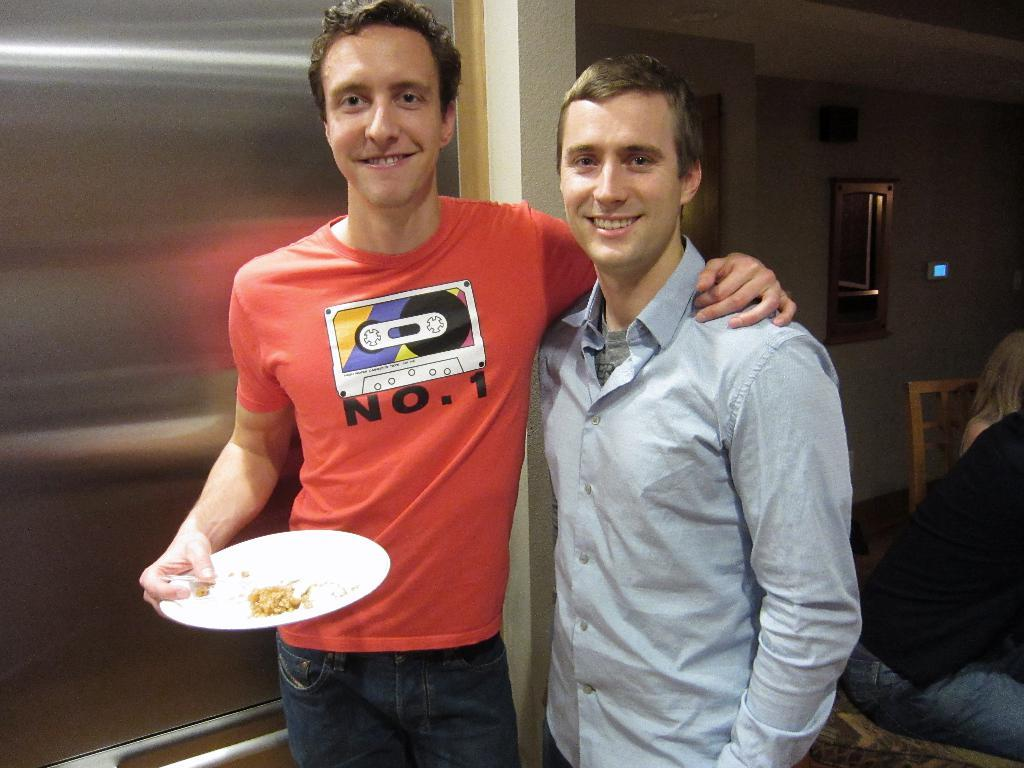How many men are in the image? There are two men standing in the image. What is the man on the left wearing? The man on the left is wearing a red t-shirt. What is the man on the left holding? The man on the left is holding a white plate with a food item. Can you describe the seating arrangement in the image? There are two people sitting at the left side of the image. What can be seen in the background of the image? There is a mirror visible in the background of the image. What political theory does the governor discuss with the men in the image? There is no governor present in the image, and therefore no political theory can be discussed. 